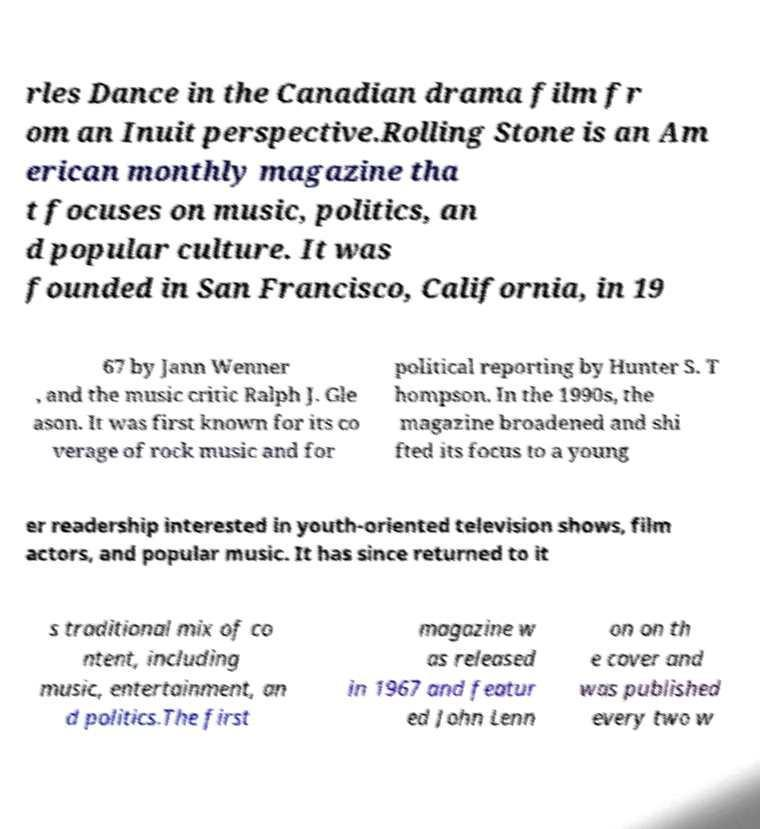Can you read and provide the text displayed in the image?This photo seems to have some interesting text. Can you extract and type it out for me? rles Dance in the Canadian drama film fr om an Inuit perspective.Rolling Stone is an Am erican monthly magazine tha t focuses on music, politics, an d popular culture. It was founded in San Francisco, California, in 19 67 by Jann Wenner , and the music critic Ralph J. Gle ason. It was first known for its co verage of rock music and for political reporting by Hunter S. T hompson. In the 1990s, the magazine broadened and shi fted its focus to a young er readership interested in youth-oriented television shows, film actors, and popular music. It has since returned to it s traditional mix of co ntent, including music, entertainment, an d politics.The first magazine w as released in 1967 and featur ed John Lenn on on th e cover and was published every two w 